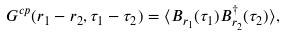<formula> <loc_0><loc_0><loc_500><loc_500>G ^ { c p } ( { r } _ { 1 } - { r } _ { 2 } , \tau _ { 1 } - \tau _ { 2 } ) = \langle B _ { { r } _ { 1 } } ( \tau _ { 1 } ) B ^ { \dagger } _ { { r } _ { 2 } } ( \tau _ { 2 } ) \rangle ,</formula> 